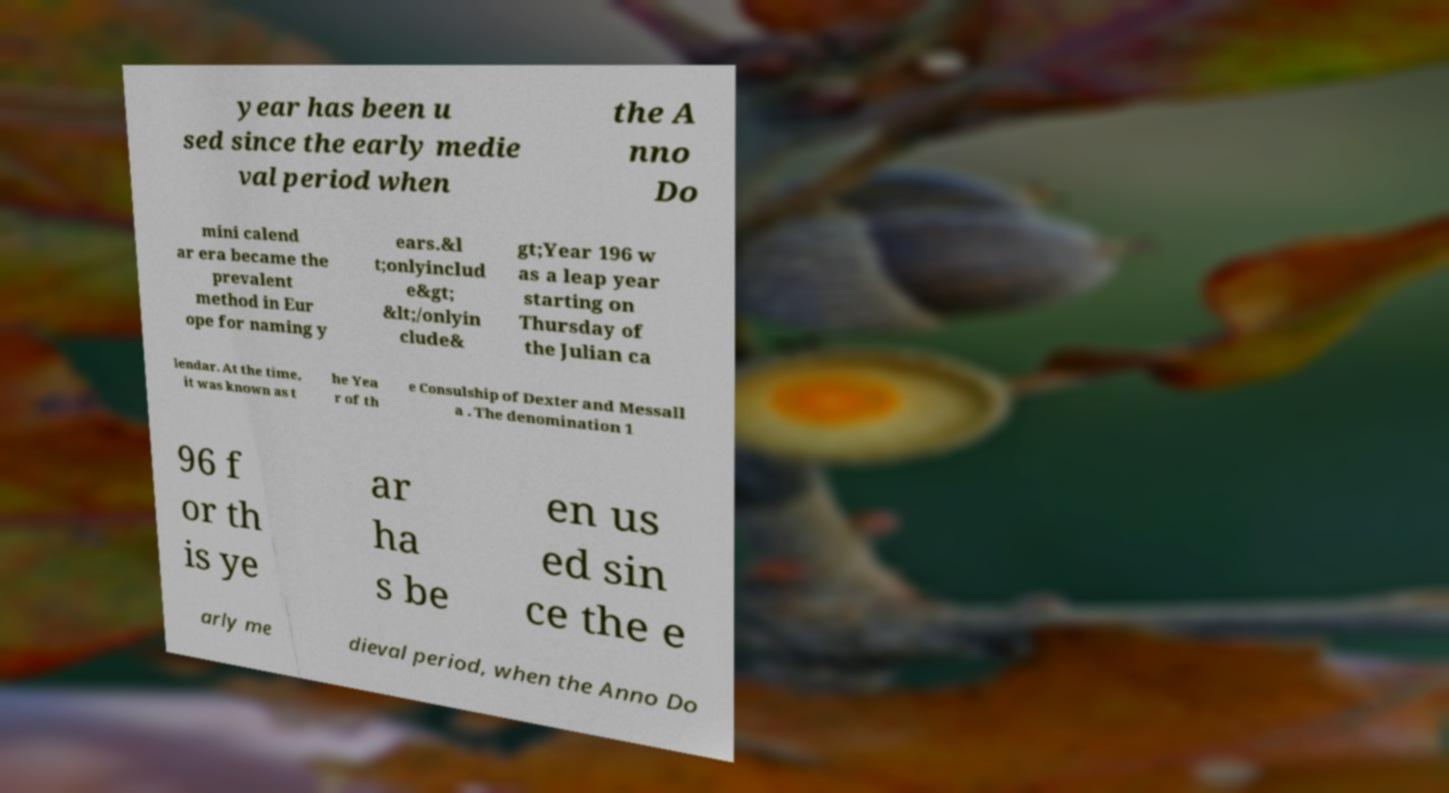Please read and relay the text visible in this image. What does it say? year has been u sed since the early medie val period when the A nno Do mini calend ar era became the prevalent method in Eur ope for naming y ears.&l t;onlyinclud e&gt; &lt;/onlyin clude& gt;Year 196 w as a leap year starting on Thursday of the Julian ca lendar. At the time, it was known as t he Yea r of th e Consulship of Dexter and Messall a . The denomination 1 96 f or th is ye ar ha s be en us ed sin ce the e arly me dieval period, when the Anno Do 